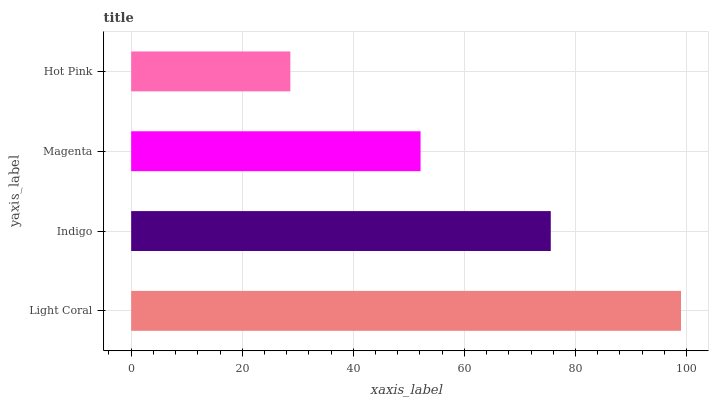Is Hot Pink the minimum?
Answer yes or no. Yes. Is Light Coral the maximum?
Answer yes or no. Yes. Is Indigo the minimum?
Answer yes or no. No. Is Indigo the maximum?
Answer yes or no. No. Is Light Coral greater than Indigo?
Answer yes or no. Yes. Is Indigo less than Light Coral?
Answer yes or no. Yes. Is Indigo greater than Light Coral?
Answer yes or no. No. Is Light Coral less than Indigo?
Answer yes or no. No. Is Indigo the high median?
Answer yes or no. Yes. Is Magenta the low median?
Answer yes or no. Yes. Is Hot Pink the high median?
Answer yes or no. No. Is Light Coral the low median?
Answer yes or no. No. 